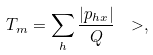<formula> <loc_0><loc_0><loc_500><loc_500>T _ { m } = \sum _ { h } \frac { | p _ { h x } | } { Q } \ > ,</formula> 